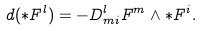Convert formula to latex. <formula><loc_0><loc_0><loc_500><loc_500>d ( \ast F ^ { l } ) = - D _ { m i } ^ { l } F ^ { m } \wedge \ast F ^ { i } .</formula> 